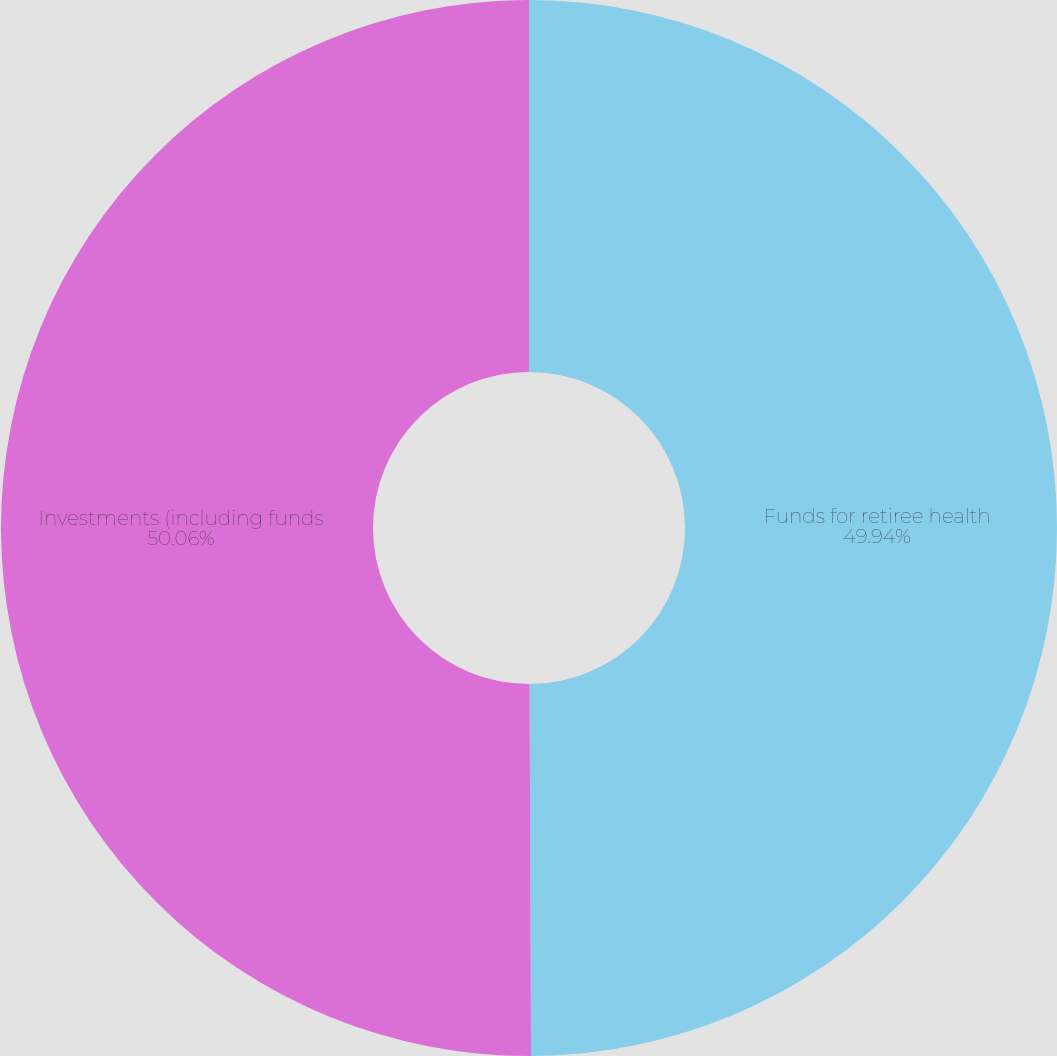Convert chart. <chart><loc_0><loc_0><loc_500><loc_500><pie_chart><fcel>Funds for retiree health<fcel>Investments (including funds<nl><fcel>49.94%<fcel>50.06%<nl></chart> 